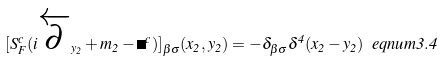<formula> <loc_0><loc_0><loc_500><loc_500>[ S _ { F } ^ { c } ( i \overleftarrow { \partial } _ { y _ { 2 } } + m _ { 2 } - \Sigma ^ { c } ) ] _ { \beta \sigma } ( x _ { 2 } , y _ { 2 } ) = - \delta _ { \beta \sigma } \delta ^ { 4 } ( x _ { 2 } - y _ { 2 } ) \ e q n u m { 3 . 4 }</formula> 